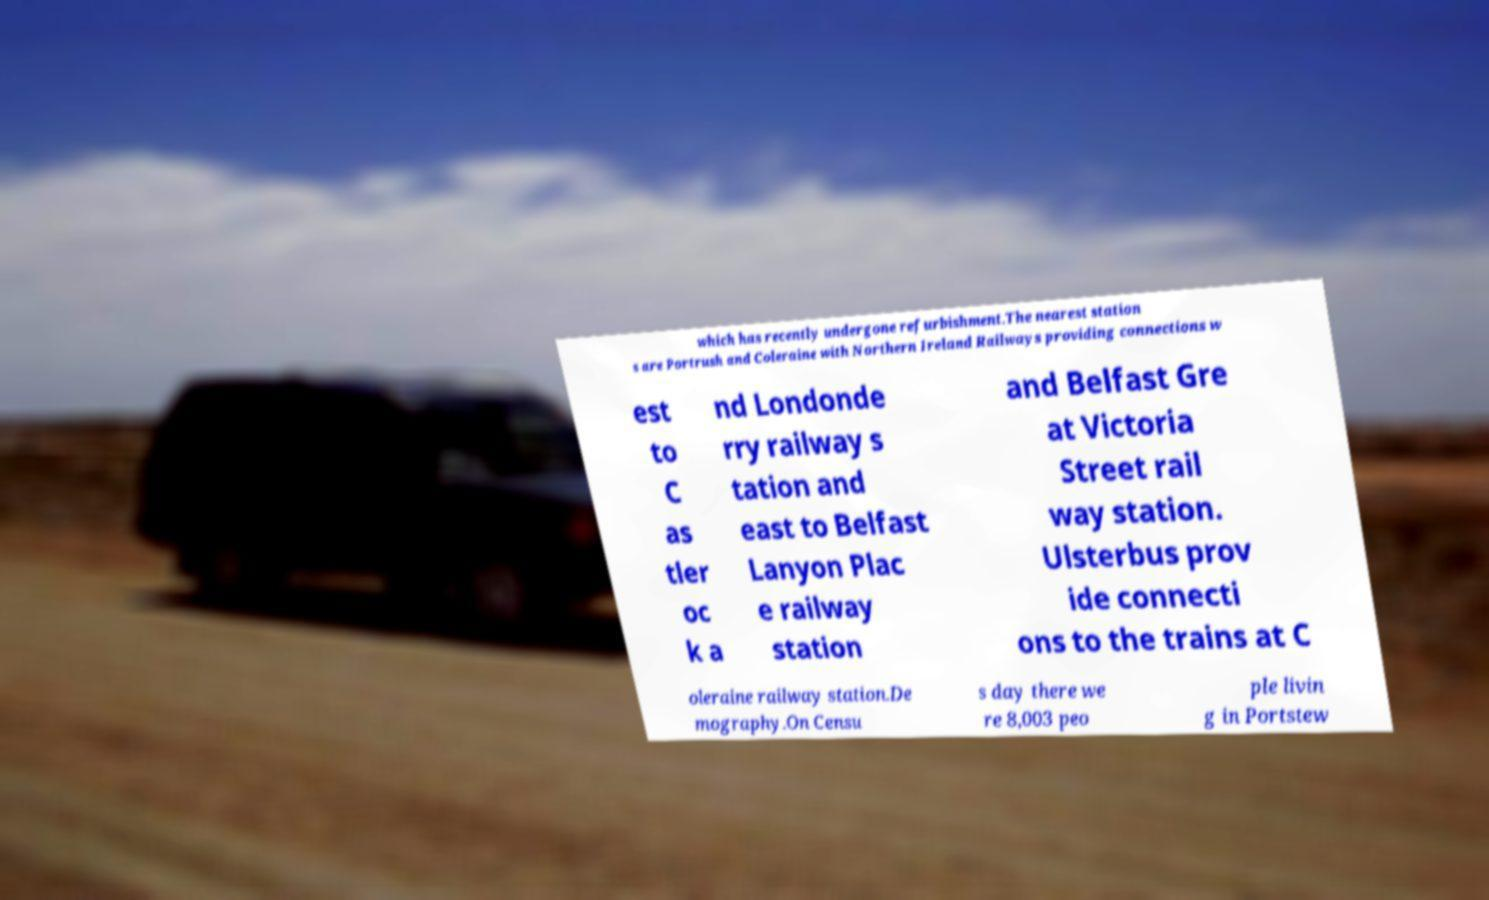Please identify and transcribe the text found in this image. which has recently undergone refurbishment.The nearest station s are Portrush and Coleraine with Northern Ireland Railways providing connections w est to C as tler oc k a nd Londonde rry railway s tation and east to Belfast Lanyon Plac e railway station and Belfast Gre at Victoria Street rail way station. Ulsterbus prov ide connecti ons to the trains at C oleraine railway station.De mography.On Censu s day there we re 8,003 peo ple livin g in Portstew 